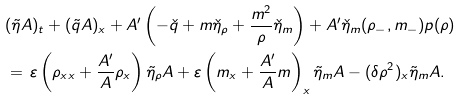<formula> <loc_0><loc_0><loc_500><loc_500>& ( \tilde { \eta } A ) _ { t } + ( \tilde { q } A ) _ { x } + A ^ { \prime } \left ( - \check { q } + m \check { \eta } _ { \rho } + \frac { m ^ { 2 } } { \rho } \check { \eta } _ { m } \right ) + A ^ { \prime } \check { \eta } _ { m } ( \rho _ { - } , m _ { - } ) p ( \rho ) \\ & = \, \varepsilon \left ( \rho _ { x x } + \frac { A ^ { \prime } } { A } \rho _ { x } \right ) \tilde { \eta } _ { \rho } A + \varepsilon \left ( m _ { x } + \frac { A ^ { \prime } } { A } m \right ) _ { x } \tilde { \eta } _ { m } A - ( \delta \rho ^ { 2 } ) _ { x } \tilde { \eta } _ { m } A .</formula> 